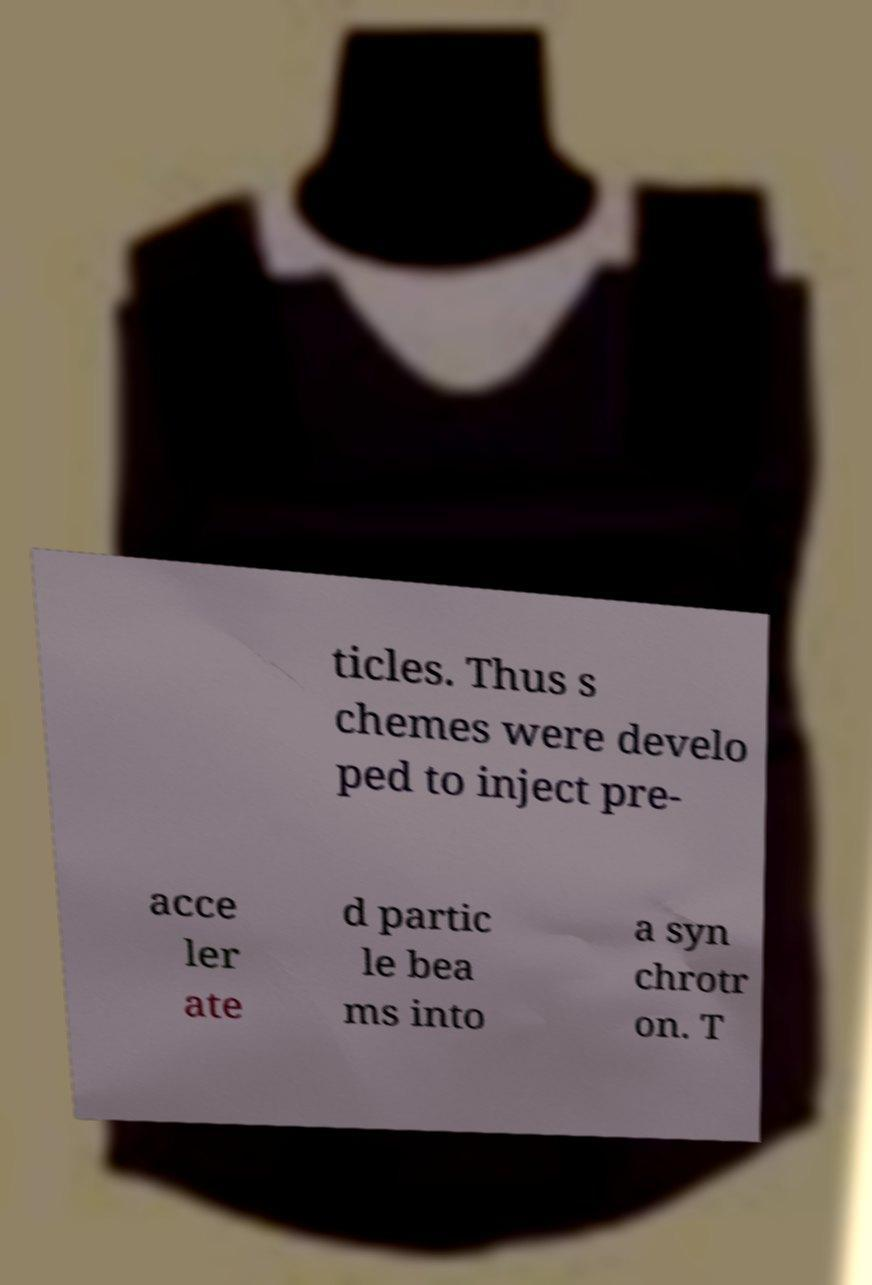Could you extract and type out the text from this image? ticles. Thus s chemes were develo ped to inject pre- acce ler ate d partic le bea ms into a syn chrotr on. T 